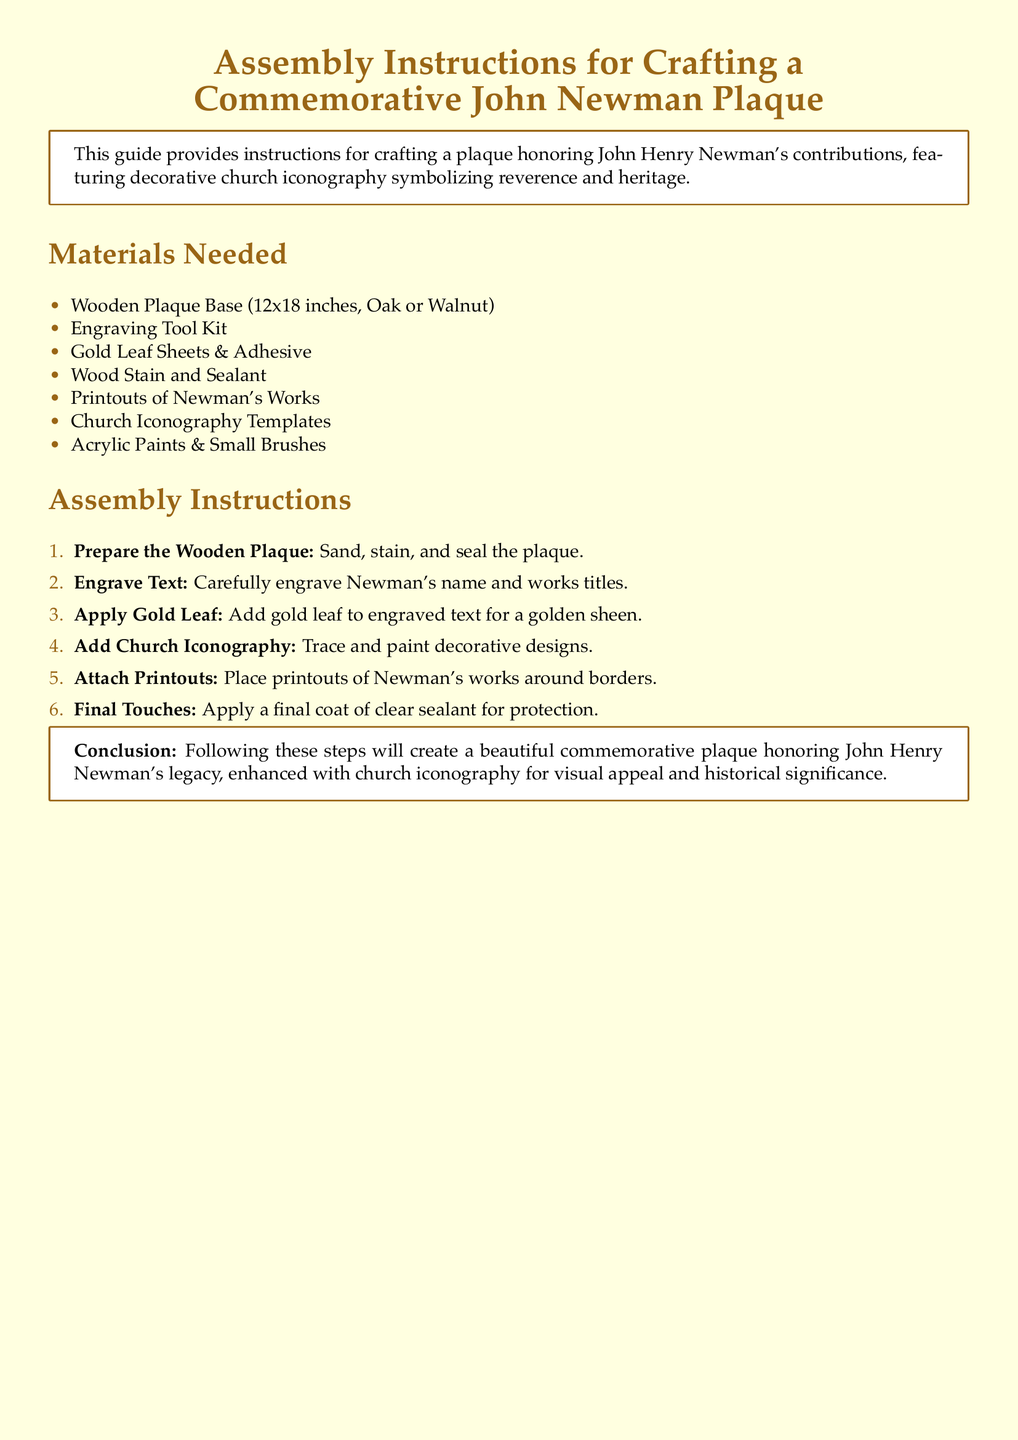What is the size of the wooden plaque base? The size of the wooden plaque base is specified in the materials section, which states 12x18 inches.
Answer: 12x18 inches What materials are needed for the assembly? The materials needed are listed in a bulleted format, including various items such as wood, engraving tools, and decorative elements.
Answer: Wooden Plaque Base, Engraving Tool Kit, Gold Leaf Sheets & Adhesive, Wood Stain and Sealant, Printouts of Newman's Works, Church Iconography Templates, Acrylic Paints & Small Brushes How many assembly instructions are provided? The number of assembly instructions is counted from the enumerated list in the document, which shows six steps.
Answer: 6 What is the purpose of applying gold leaf? The purpose of applying gold leaf is mentioned in the instructions, stating it adds a golden sheen to the engraved text.
Answer: Golden sheen What is the final step in the assembly instructions? The final step is described as applying a coat of clear sealant in the list of assembly instructions.
Answer: Apply a final coat of clear sealant What type of document is this? This document is specifically designed as assembly instructions for creating a commemorative plaque, as indicated in the title.
Answer: Assembly instructions 